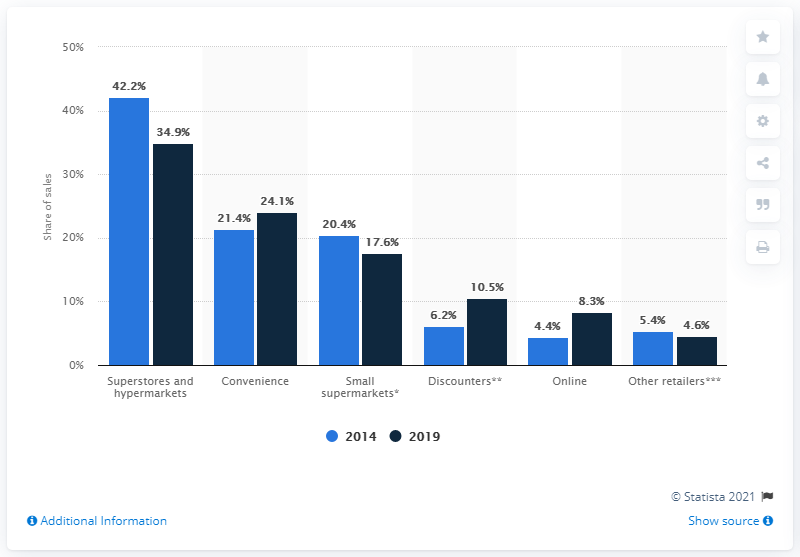Outline some significant characteristics in this image. According to data from 2014, grocery retail sales accounted for a significant portion of the overall retail market in the United Kingdom. In 2019, it is projected that grocery retail sales will account for 34.9% of the overall retail market. According to data from 2014, grocery retail sales accounted for 42.2% of the total retail sales in the United Kingdom. 